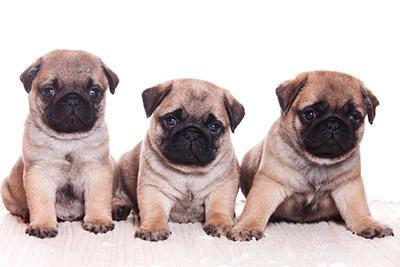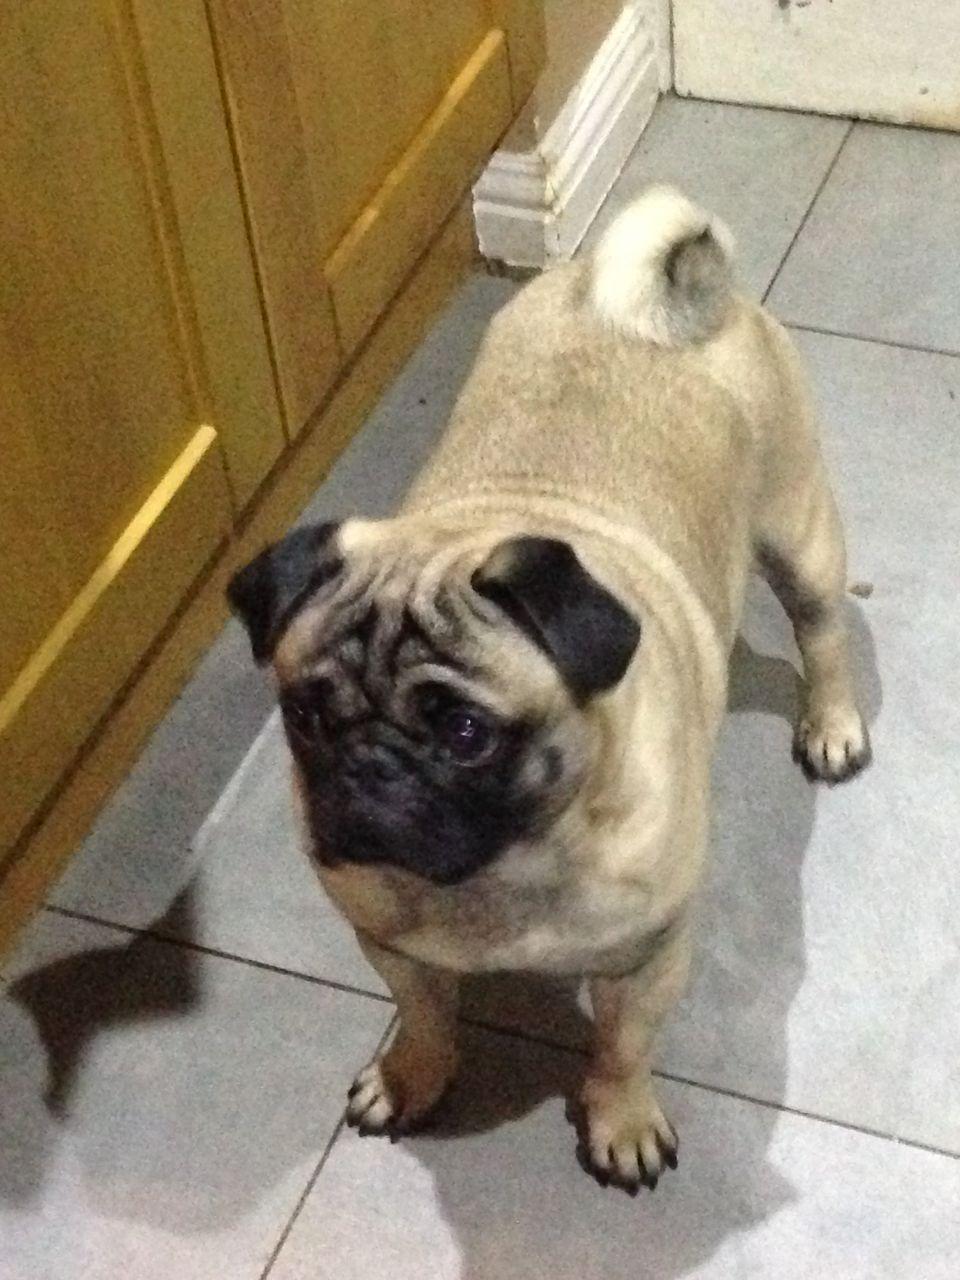The first image is the image on the left, the second image is the image on the right. Analyze the images presented: Is the assertion "There are exactly three dogs in the right image." valid? Answer yes or no. No. The first image is the image on the left, the second image is the image on the right. Considering the images on both sides, is "Each image contains multiple pugs, and one image shows a trio of pugs with a black one in the middle." valid? Answer yes or no. No. 